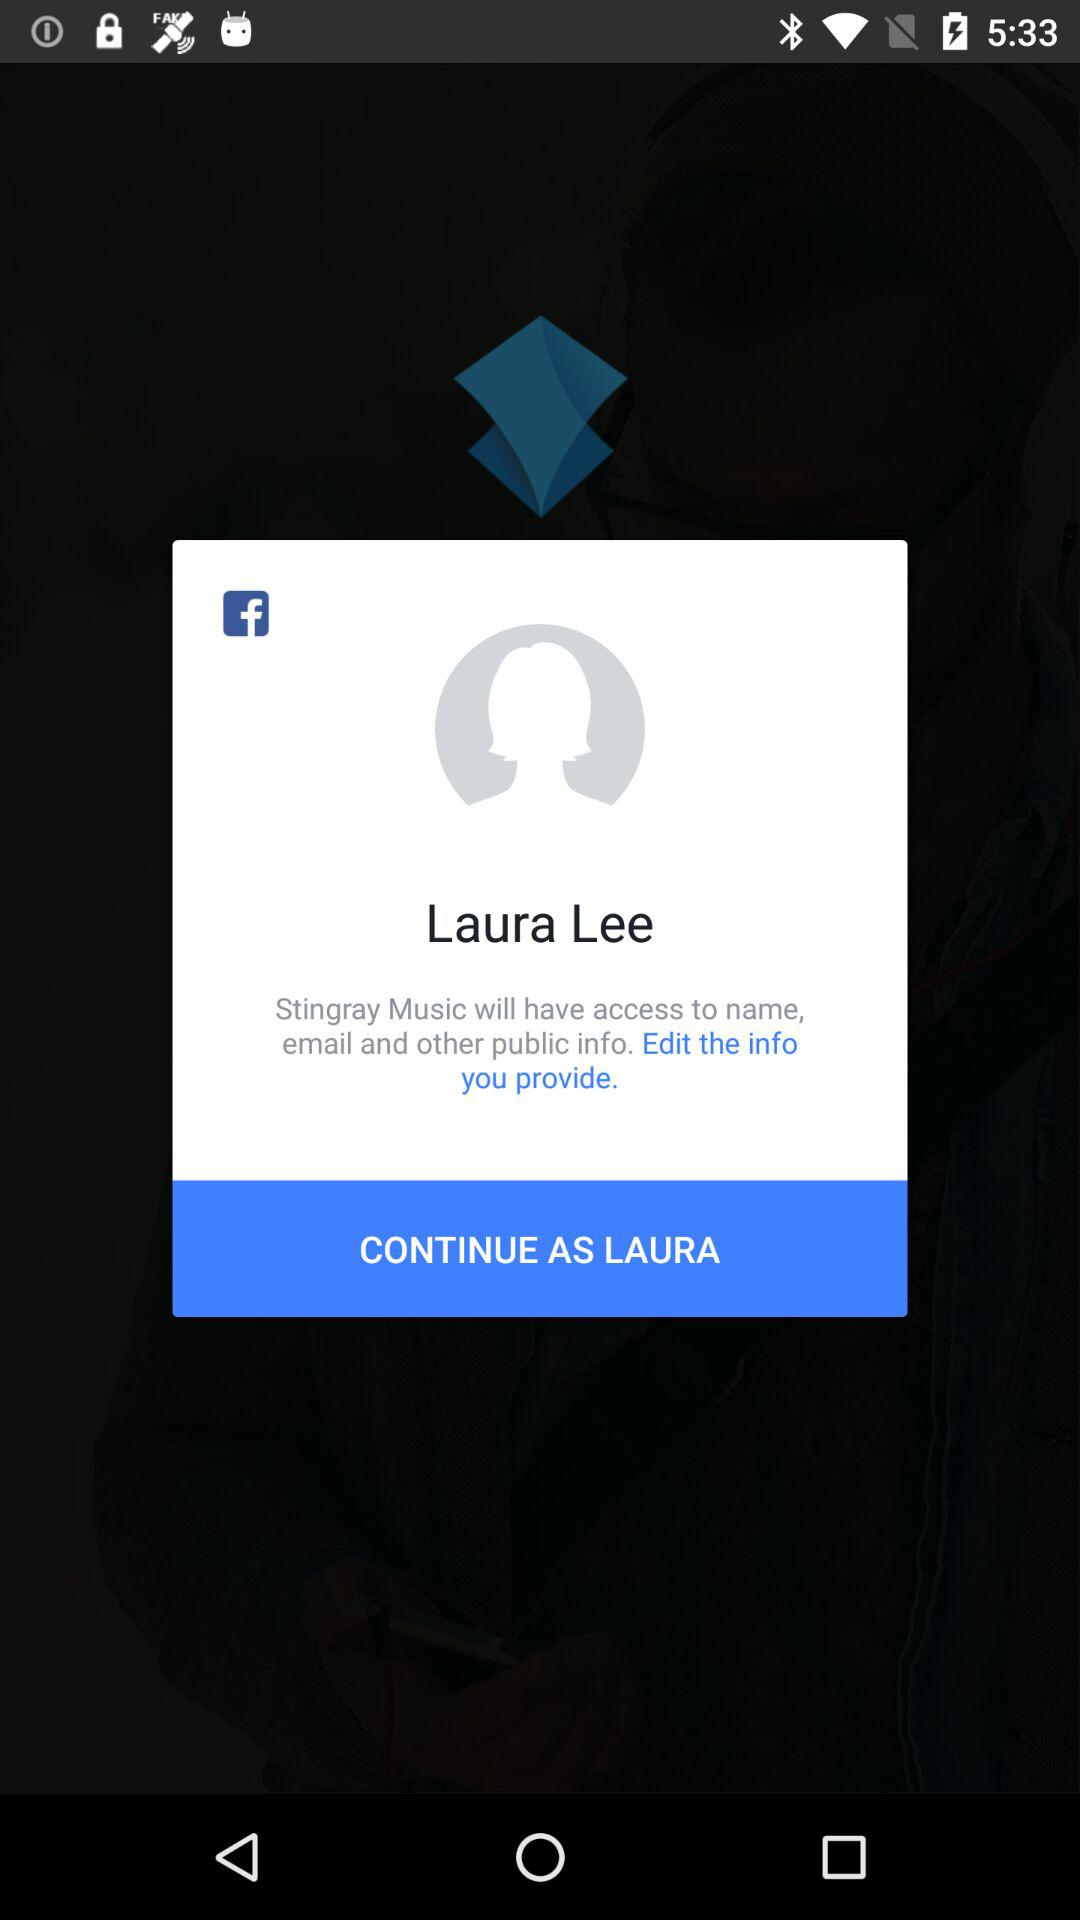What is the user name? The user name is "Laura Lee". 